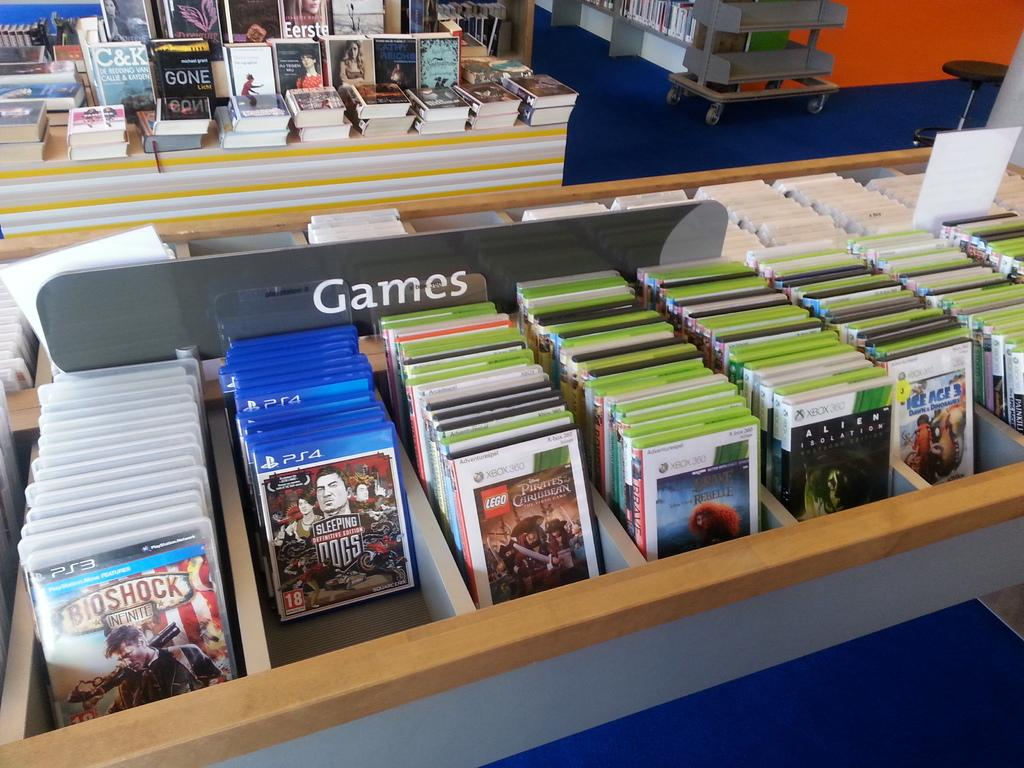<image>
Present a compact description of the photo's key features. A row of PS4, PS3 and Xbox360 games is on display in the games section 